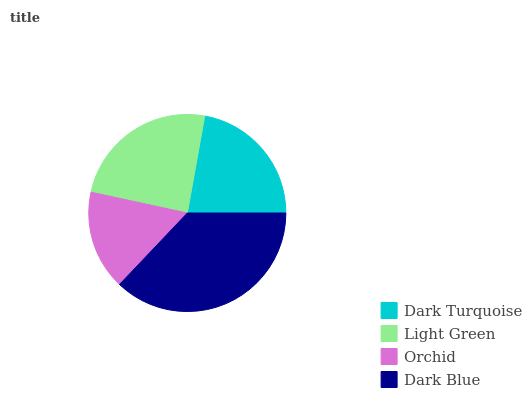Is Orchid the minimum?
Answer yes or no. Yes. Is Dark Blue the maximum?
Answer yes or no. Yes. Is Light Green the minimum?
Answer yes or no. No. Is Light Green the maximum?
Answer yes or no. No. Is Light Green greater than Dark Turquoise?
Answer yes or no. Yes. Is Dark Turquoise less than Light Green?
Answer yes or no. Yes. Is Dark Turquoise greater than Light Green?
Answer yes or no. No. Is Light Green less than Dark Turquoise?
Answer yes or no. No. Is Light Green the high median?
Answer yes or no. Yes. Is Dark Turquoise the low median?
Answer yes or no. Yes. Is Dark Blue the high median?
Answer yes or no. No. Is Orchid the low median?
Answer yes or no. No. 